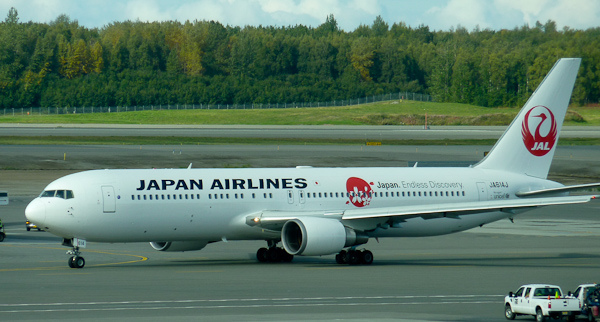Read and extract the text from this image. JAPAN AIRPLANES Japan Discovery JAL 